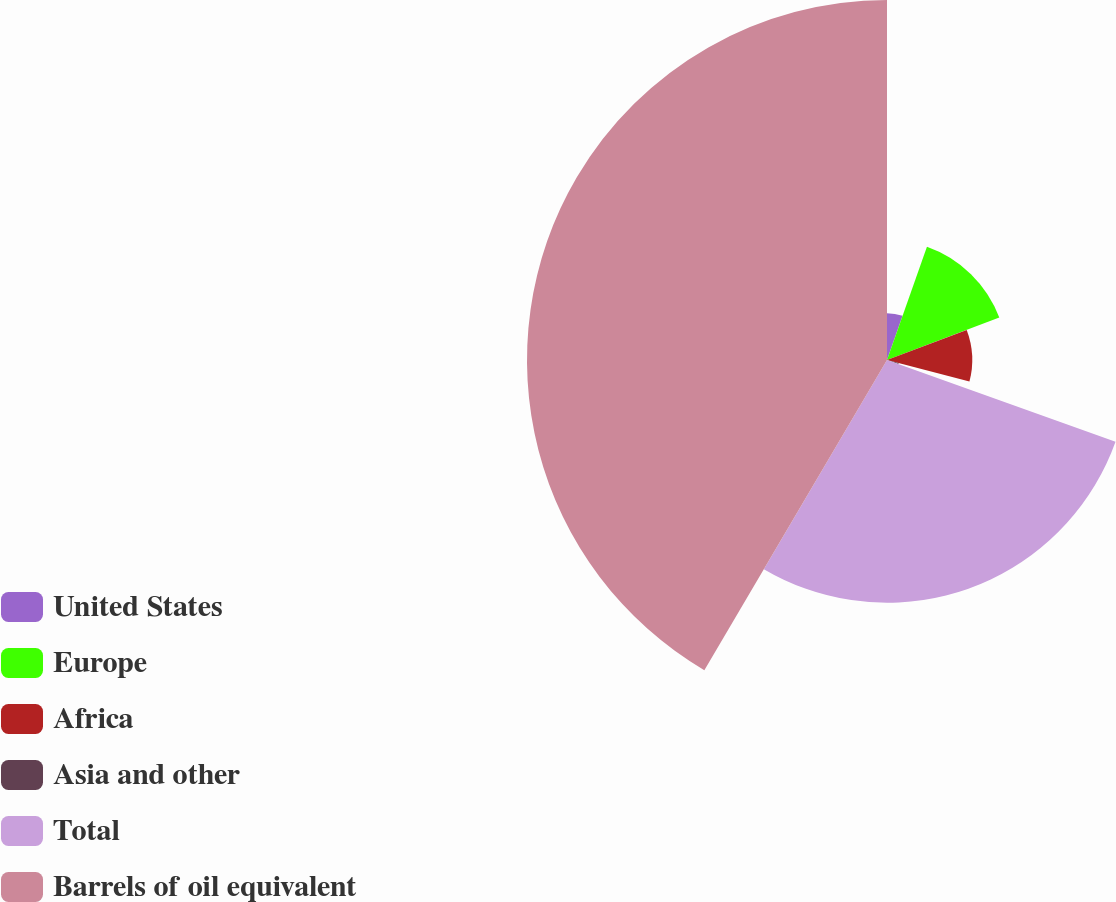<chart> <loc_0><loc_0><loc_500><loc_500><pie_chart><fcel>United States<fcel>Europe<fcel>Africa<fcel>Asia and other<fcel>Total<fcel>Barrels of oil equivalent<nl><fcel>5.4%<fcel>13.85%<fcel>9.83%<fcel>1.39%<fcel>28.0%<fcel>41.53%<nl></chart> 